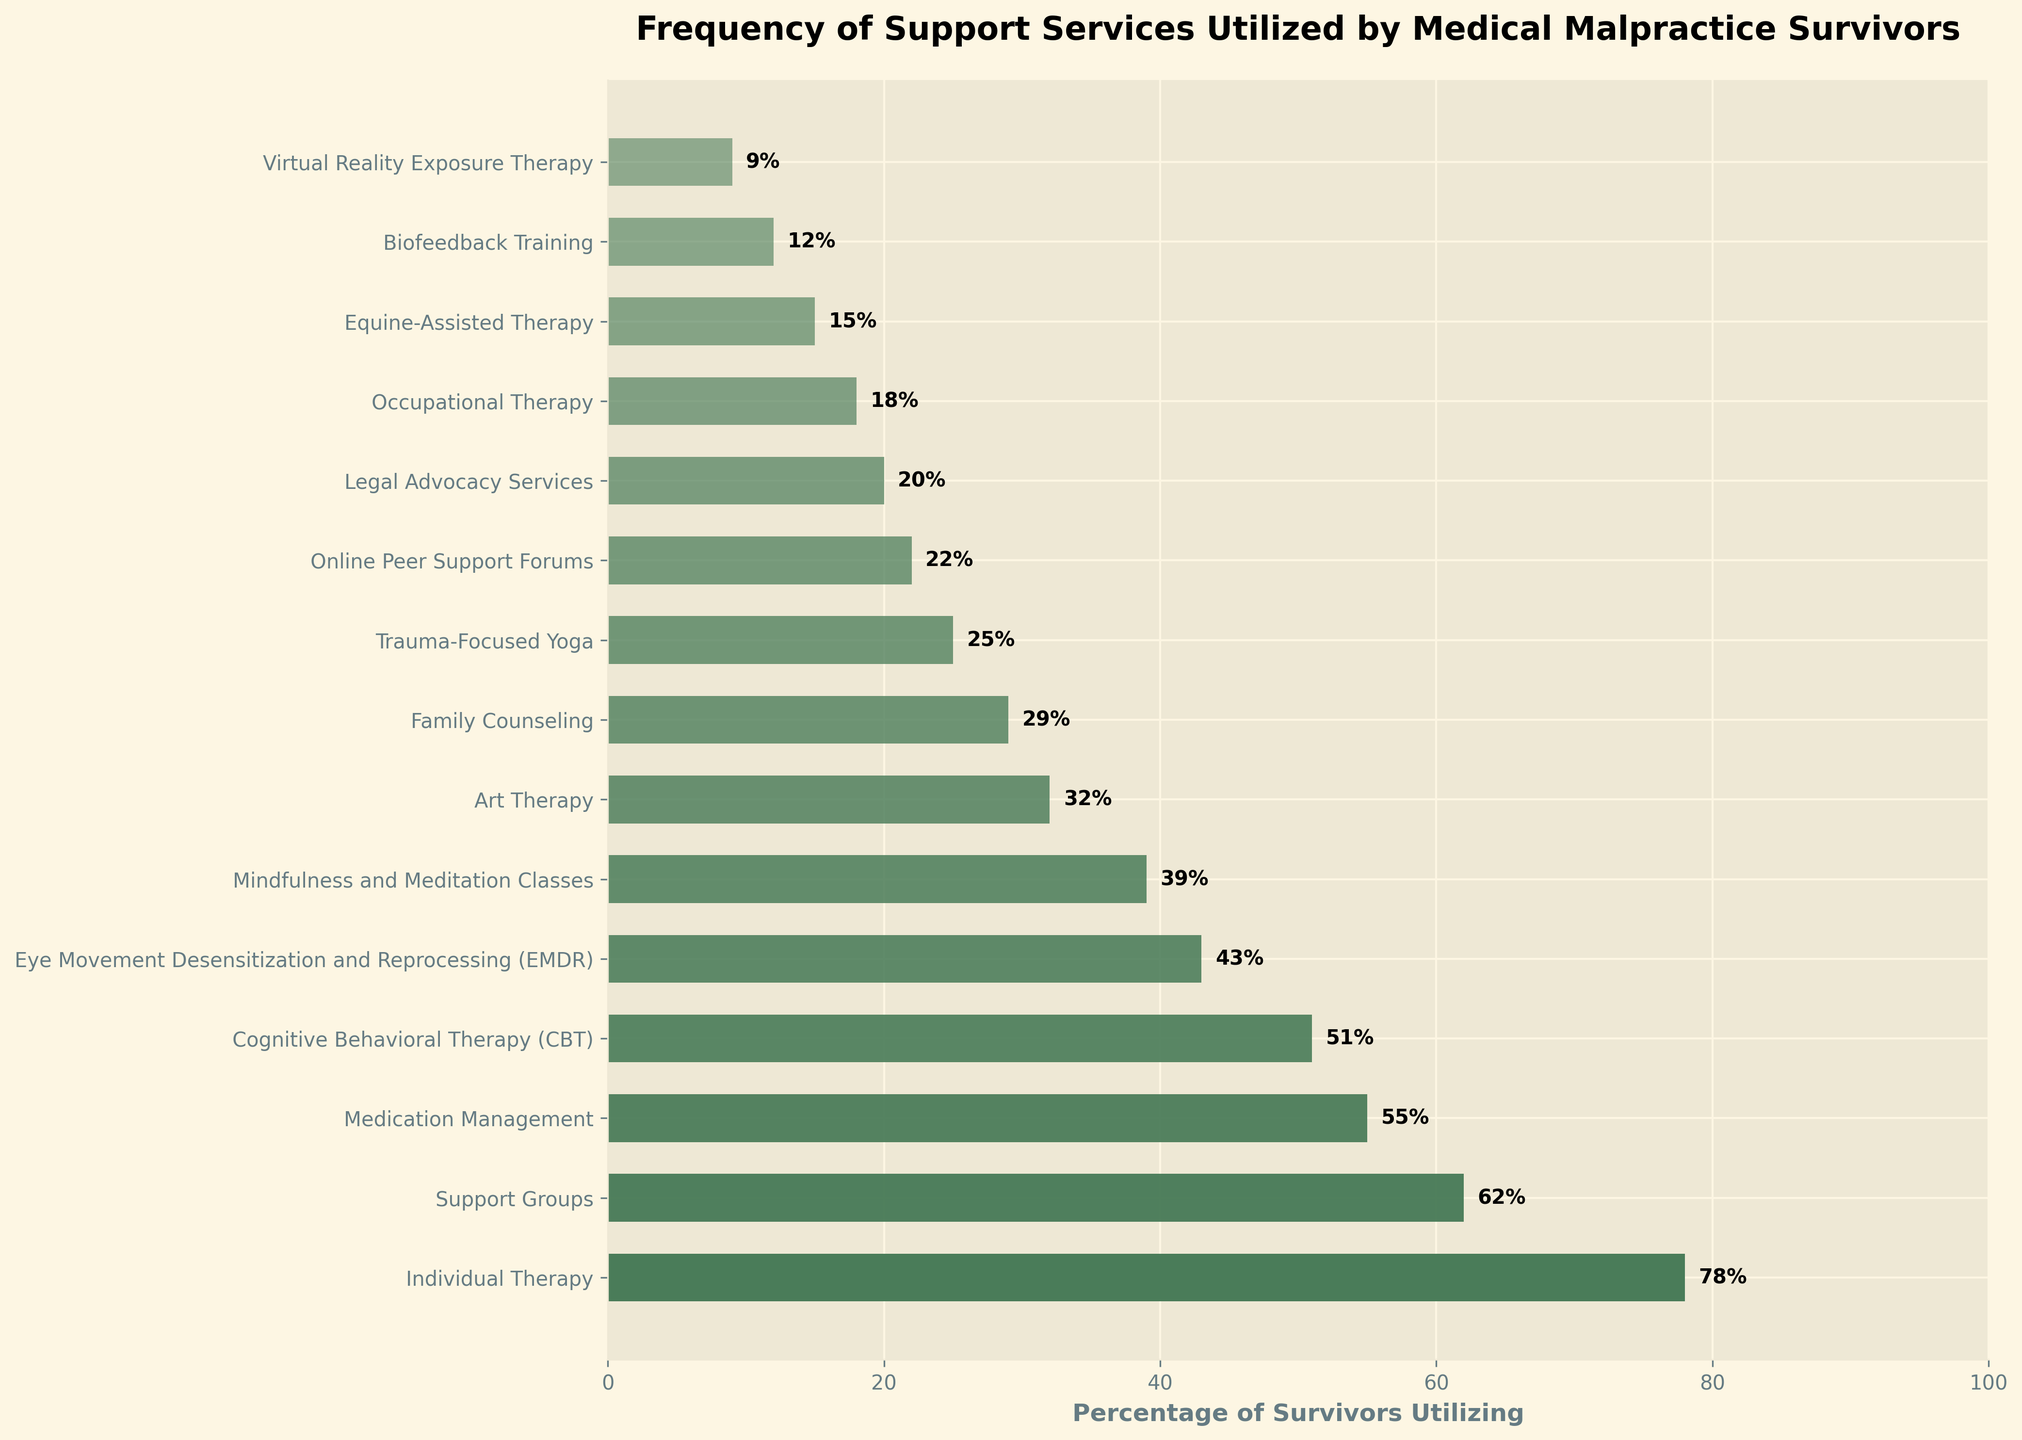Which support service is utilized by the highest percentage of survivors? The highest bar in the chart represents individual therapy, which is at the top and has 78% utilization.
Answer: Individual Therapy Which two support services have almost similar utilization percentages? Both Cognitive Behavioral Therapy (CBT) and Medication Management have close values of 51% and 55% respectively.
Answer: Cognitive Behavioral Therapy (CBT) and Medication Management What is the total percentage of survivors utilizing Eye Movement Desensitization and Reprocessing (EMDR) and Trauma-Focused Yoga combined? The percentage for EMDR is 43%, and the percentage for Trauma-Focused Yoga is 25%. Adding these together, 43 + 25 = 68%.
Answer: 68% How much higher is the utilization of Support Groups compared to Virtual Reality Exposure Therapy? Support Groups have a utilization of 62%, while Virtual Reality Exposure Therapy has 9%. The difference is 62 - 9 = 53%.
Answer: 53% Which support service has a slightly lower utilization rate than Cognitive Behavioral Therapy (CBT)? Eye Movement Desensitization and Reprocessing (EMDR) has a utilization rate of 43%, which is just below CBT's 51%.
Answer: Eye Movement Desensitization and Reprocessing (EMDR) What is the average utilization percentage of the listed support services? Sum the percentages: 78 + 62 + 55 + 51 + 43 + 39 + 32 + 29 + 25 + 22 + 20 + 18 + 15 + 12 + 9 = 510. There are 15 services, so the average is 510 / 15 = 34%.
Answer: 34% How does the utilization of Art Therapy compare to Family Counseling visually? Both bars are at similar levels, with Art Therapy at 32% and Family Counseling at 29%, showing close utilization rates.
Answer: Art Therapy is slightly higher Which support service has the least utilization, and by how much does it differ from the next least utilized service? Virtual Reality Exposure Therapy has the least utilization at 9%, and the next least is Biofeedback Training at 12%. The difference is 12 - 9 = 3%.
Answer: Virtual Reality Exposure Therapy by 3% What is the visual pattern in the opacity of bars from top to bottom? The top bars are more opaque (darker), and as you move down, the bars become less opaque (lighter), following a gradual decrease in opacity.
Answer: Decreasing opacity from top to bottom 